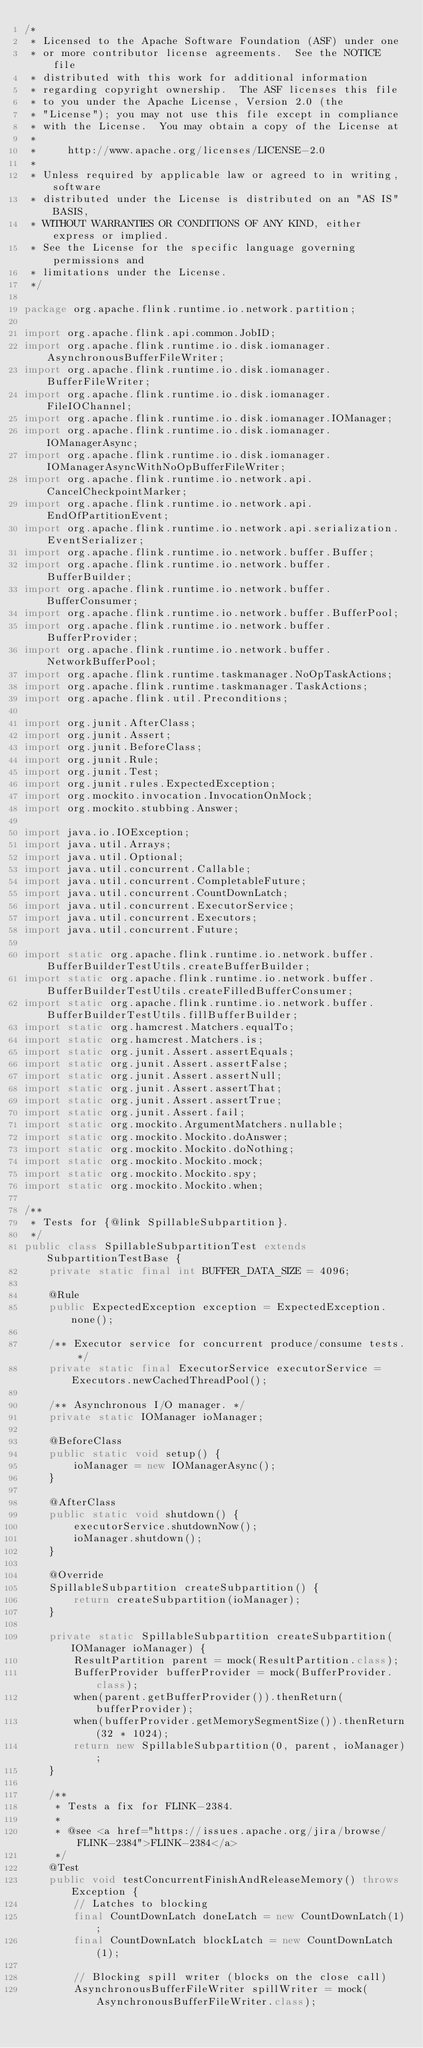Convert code to text. <code><loc_0><loc_0><loc_500><loc_500><_Java_>/*
 * Licensed to the Apache Software Foundation (ASF) under one
 * or more contributor license agreements.  See the NOTICE file
 * distributed with this work for additional information
 * regarding copyright ownership.  The ASF licenses this file
 * to you under the Apache License, Version 2.0 (the
 * "License"); you may not use this file except in compliance
 * with the License.  You may obtain a copy of the License at
 *
 *     http://www.apache.org/licenses/LICENSE-2.0
 *
 * Unless required by applicable law or agreed to in writing, software
 * distributed under the License is distributed on an "AS IS" BASIS,
 * WITHOUT WARRANTIES OR CONDITIONS OF ANY KIND, either express or implied.
 * See the License for the specific language governing permissions and
 * limitations under the License.
 */

package org.apache.flink.runtime.io.network.partition;

import org.apache.flink.api.common.JobID;
import org.apache.flink.runtime.io.disk.iomanager.AsynchronousBufferFileWriter;
import org.apache.flink.runtime.io.disk.iomanager.BufferFileWriter;
import org.apache.flink.runtime.io.disk.iomanager.FileIOChannel;
import org.apache.flink.runtime.io.disk.iomanager.IOManager;
import org.apache.flink.runtime.io.disk.iomanager.IOManagerAsync;
import org.apache.flink.runtime.io.disk.iomanager.IOManagerAsyncWithNoOpBufferFileWriter;
import org.apache.flink.runtime.io.network.api.CancelCheckpointMarker;
import org.apache.flink.runtime.io.network.api.EndOfPartitionEvent;
import org.apache.flink.runtime.io.network.api.serialization.EventSerializer;
import org.apache.flink.runtime.io.network.buffer.Buffer;
import org.apache.flink.runtime.io.network.buffer.BufferBuilder;
import org.apache.flink.runtime.io.network.buffer.BufferConsumer;
import org.apache.flink.runtime.io.network.buffer.BufferPool;
import org.apache.flink.runtime.io.network.buffer.BufferProvider;
import org.apache.flink.runtime.io.network.buffer.NetworkBufferPool;
import org.apache.flink.runtime.taskmanager.NoOpTaskActions;
import org.apache.flink.runtime.taskmanager.TaskActions;
import org.apache.flink.util.Preconditions;

import org.junit.AfterClass;
import org.junit.Assert;
import org.junit.BeforeClass;
import org.junit.Rule;
import org.junit.Test;
import org.junit.rules.ExpectedException;
import org.mockito.invocation.InvocationOnMock;
import org.mockito.stubbing.Answer;

import java.io.IOException;
import java.util.Arrays;
import java.util.Optional;
import java.util.concurrent.Callable;
import java.util.concurrent.CompletableFuture;
import java.util.concurrent.CountDownLatch;
import java.util.concurrent.ExecutorService;
import java.util.concurrent.Executors;
import java.util.concurrent.Future;

import static org.apache.flink.runtime.io.network.buffer.BufferBuilderTestUtils.createBufferBuilder;
import static org.apache.flink.runtime.io.network.buffer.BufferBuilderTestUtils.createFilledBufferConsumer;
import static org.apache.flink.runtime.io.network.buffer.BufferBuilderTestUtils.fillBufferBuilder;
import static org.hamcrest.Matchers.equalTo;
import static org.hamcrest.Matchers.is;
import static org.junit.Assert.assertEquals;
import static org.junit.Assert.assertFalse;
import static org.junit.Assert.assertNull;
import static org.junit.Assert.assertThat;
import static org.junit.Assert.assertTrue;
import static org.junit.Assert.fail;
import static org.mockito.ArgumentMatchers.nullable;
import static org.mockito.Mockito.doAnswer;
import static org.mockito.Mockito.doNothing;
import static org.mockito.Mockito.mock;
import static org.mockito.Mockito.spy;
import static org.mockito.Mockito.when;

/**
 * Tests for {@link SpillableSubpartition}.
 */
public class SpillableSubpartitionTest extends SubpartitionTestBase {
	private static final int BUFFER_DATA_SIZE = 4096;

	@Rule
	public ExpectedException exception = ExpectedException.none();

	/** Executor service for concurrent produce/consume tests. */
	private static final ExecutorService executorService = Executors.newCachedThreadPool();

	/** Asynchronous I/O manager. */
	private static IOManager ioManager;

	@BeforeClass
	public static void setup() {
		ioManager = new IOManagerAsync();
	}

	@AfterClass
	public static void shutdown() {
		executorService.shutdownNow();
		ioManager.shutdown();
	}

	@Override
	SpillableSubpartition createSubpartition() {
		return createSubpartition(ioManager);
	}

	private static SpillableSubpartition createSubpartition(IOManager ioManager) {
		ResultPartition parent = mock(ResultPartition.class);
		BufferProvider bufferProvider = mock(BufferProvider.class);
		when(parent.getBufferProvider()).thenReturn(bufferProvider);
		when(bufferProvider.getMemorySegmentSize()).thenReturn(32 * 1024);
		return new SpillableSubpartition(0, parent, ioManager);
	}

	/**
	 * Tests a fix for FLINK-2384.
	 *
	 * @see <a href="https://issues.apache.org/jira/browse/FLINK-2384">FLINK-2384</a>
	 */
	@Test
	public void testConcurrentFinishAndReleaseMemory() throws Exception {
		// Latches to blocking
		final CountDownLatch doneLatch = new CountDownLatch(1);
		final CountDownLatch blockLatch = new CountDownLatch(1);

		// Blocking spill writer (blocks on the close call)
		AsynchronousBufferFileWriter spillWriter = mock(AsynchronousBufferFileWriter.class);</code> 